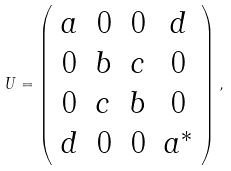Convert formula to latex. <formula><loc_0><loc_0><loc_500><loc_500>U = \left ( \begin{array} { c c c c } a & 0 & 0 & d \\ 0 & b & c & 0 \\ 0 & c & b & 0 \\ d & 0 & 0 & a ^ { * } \end{array} \right ) ,</formula> 